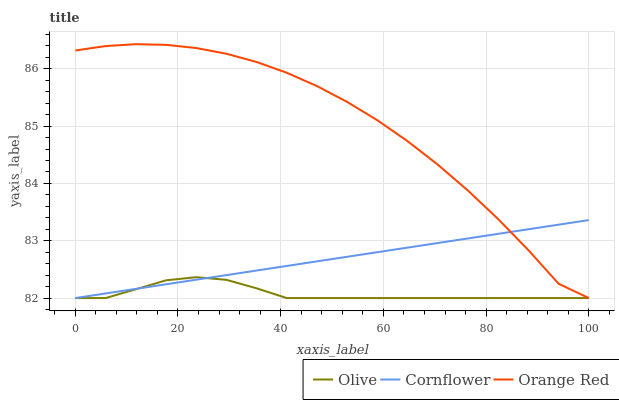Does Olive have the minimum area under the curve?
Answer yes or no. Yes. Does Orange Red have the maximum area under the curve?
Answer yes or no. Yes. Does Cornflower have the minimum area under the curve?
Answer yes or no. No. Does Cornflower have the maximum area under the curve?
Answer yes or no. No. Is Cornflower the smoothest?
Answer yes or no. Yes. Is Orange Red the roughest?
Answer yes or no. Yes. Is Orange Red the smoothest?
Answer yes or no. No. Is Cornflower the roughest?
Answer yes or no. No. Does Olive have the lowest value?
Answer yes or no. Yes. Does Orange Red have the highest value?
Answer yes or no. Yes. Does Cornflower have the highest value?
Answer yes or no. No. Does Olive intersect Orange Red?
Answer yes or no. Yes. Is Olive less than Orange Red?
Answer yes or no. No. Is Olive greater than Orange Red?
Answer yes or no. No. 